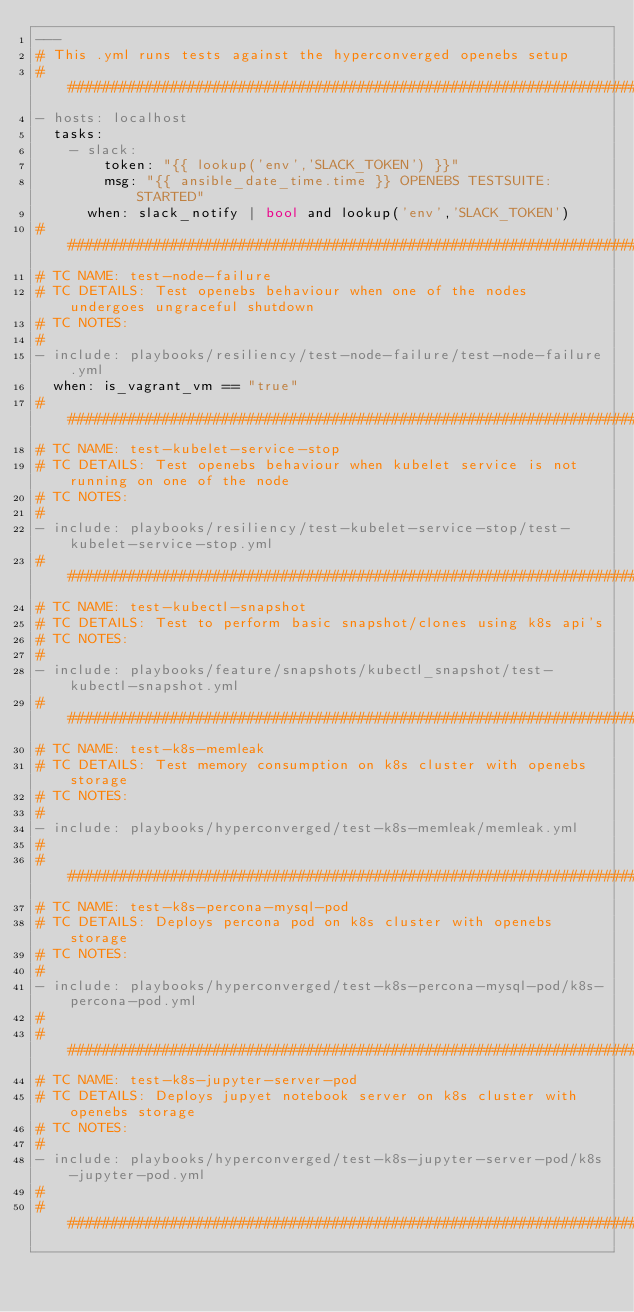<code> <loc_0><loc_0><loc_500><loc_500><_YAML_>---
# This .yml runs tests against the hyperconverged openebs setup
##########################################################################################
- hosts: localhost
  tasks:
    - slack: 
        token: "{{ lookup('env','SLACK_TOKEN') }}" 
        msg: "{{ ansible_date_time.time }} OPENEBS TESTSUITE: STARTED"
      when: slack_notify | bool and lookup('env','SLACK_TOKEN')
##########################################################################################
# TC NAME: test-node-failure
# TC DETAILS: Test openebs behaviour when one of the nodes undergoes ungraceful shutdown
# TC NOTES:
#
- include: playbooks/resiliency/test-node-failure/test-node-failure.yml
  when: is_vagrant_vm == "true"
##########################################################################################
# TC NAME: test-kubelet-service-stop
# TC DETAILS: Test openebs behaviour when kubelet service is not running on one of the node
# TC NOTES:
#
- include: playbooks/resiliency/test-kubelet-service-stop/test-kubelet-service-stop.yml
##########################################################################################
# TC NAME: test-kubectl-snapshot
# TC DETAILS: Test to perform basic snapshot/clones using k8s api's
# TC NOTES:
#
- include: playbooks/feature/snapshots/kubectl_snapshot/test-kubectl-snapshot.yml
###########################################################################################
# TC NAME: test-k8s-memleak
# TC DETAILS: Test memory consumption on k8s cluster with openebs storage
# TC NOTES:
#
- include: playbooks/hyperconverged/test-k8s-memleak/memleak.yml
#
###########################################################################################
# TC NAME: test-k8s-percona-mysql-pod
# TC DETAILS: Deploys percona pod on k8s cluster with openebs storage
# TC NOTES:           
#
- include: playbooks/hyperconverged/test-k8s-percona-mysql-pod/k8s-percona-pod.yml
#
###########################################################################################
# TC NAME: test-k8s-jupyter-server-pod 
# TC DETAILS: Deploys jupyet notebook server on k8s cluster with openebs storage
# TC NOTES:           
#    
- include: playbooks/hyperconverged/test-k8s-jupyter-server-pod/k8s-jupyter-pod.yml
#
###########################################################################################</code> 